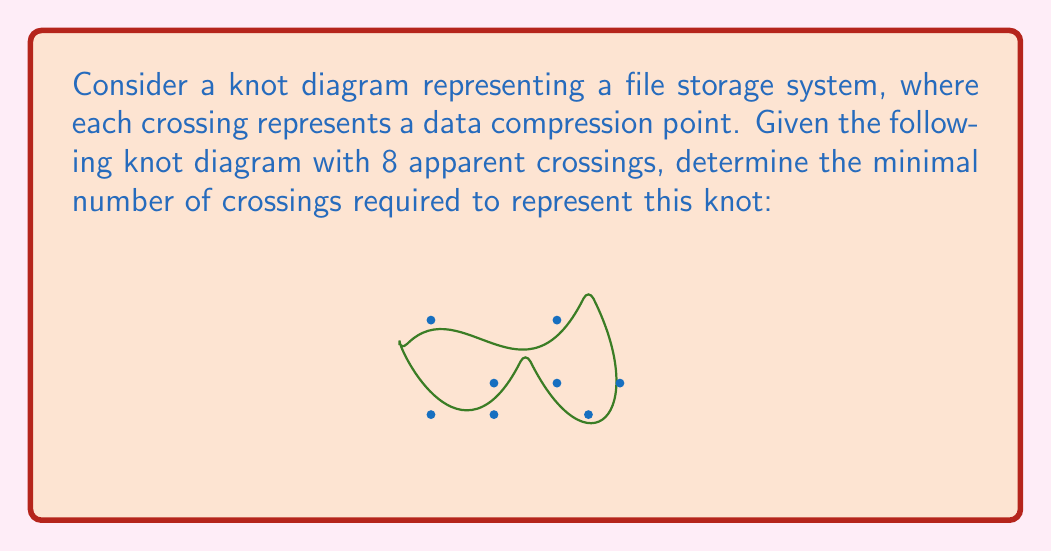Teach me how to tackle this problem. To determine the minimal number of crossings for this knot diagram, we need to follow these steps:

1) First, we need to identify if any of the crossings can be eliminated through Reidemeister moves. Reidemeister moves are operations that can be performed on a knot diagram without changing the knot type.

2) In this diagram, we can see that there are no obvious Reidemeister Type I moves (twists) that can be eliminated.

3) However, we can identify a Reidemeister Type II move near the bottom of the diagram. Two adjacent crossings can be eliminated by straightening out this section.

4) After performing this move, we're left with 6 crossings.

5) Looking at the remaining diagram, we can see that no further Reidemeister moves can be applied without potentially changing the knot type.

6) In knot theory, it's known that the trefoil knot (the simplest non-trivial knot) has a minimal crossing number of 3. Any knot with more crossings than the trefoil is likely to be more complex.

7) Given that we've reduced the diagram to 6 crossings and can't reduce it further with Reidemeister moves, we can conclude that the minimal number of crossings for this knot is 6.

8) In the context of the file storage system, this means that the data compression can be optimized to require only 6 compression points instead of the original 8.
Answer: 6 